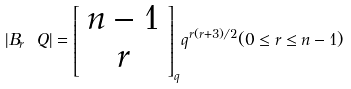Convert formula to latex. <formula><loc_0><loc_0><loc_500><loc_500>| B _ { r } \ Q | = { \left [ \begin{array} { c } n - 1 \\ r \\ \end{array} \right ] } _ { q } q ^ { r ( r + 3 ) / 2 } ( 0 \leq r \leq n - 1 )</formula> 